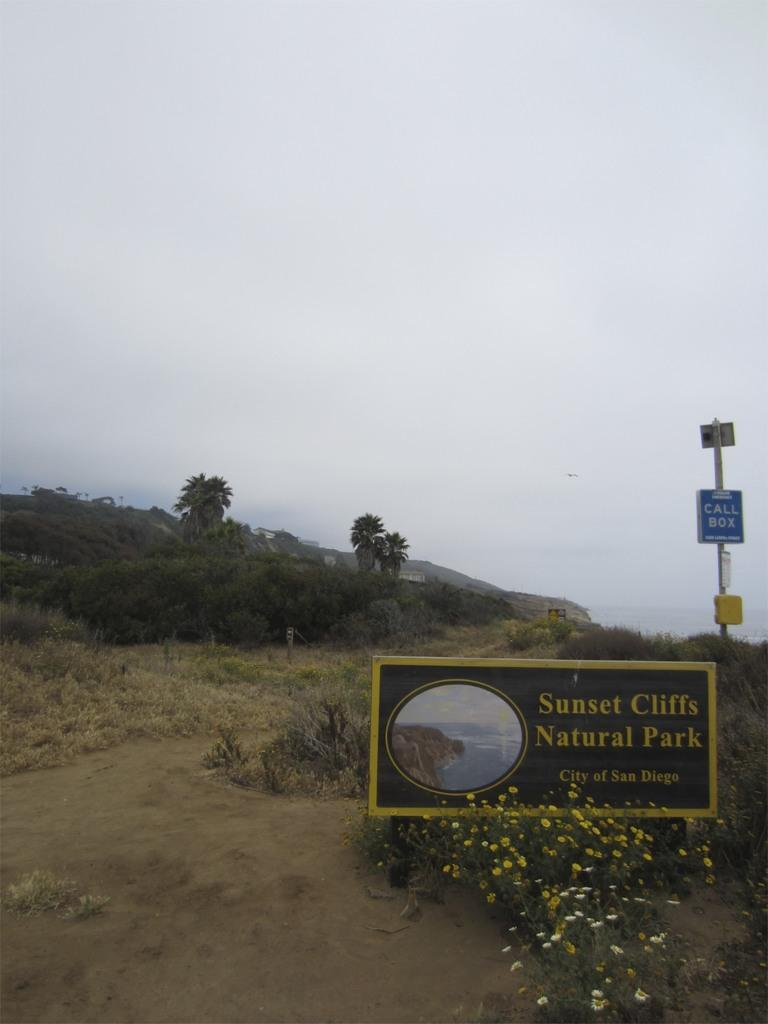What is the main object in the image? There is a name board in the image. What else can be seen in the image besides the name board? There is a pole, trees, plants, grass, flowers, a house, a hill, and the sky visible in the image. Can you describe the natural elements in the image? There are trees, plants, grass, and flowers in the image. What is the condition of the sky in the image? The sky is visible in the image, and there are clouds present. What type of corn can be seen growing on the hill in the image? There is no corn present in the image; it features a name board, pole, trees, plants, grass, flowers, a house, and a hill, but no corn. What is the tin used for in the image? There is no tin present in the image. 